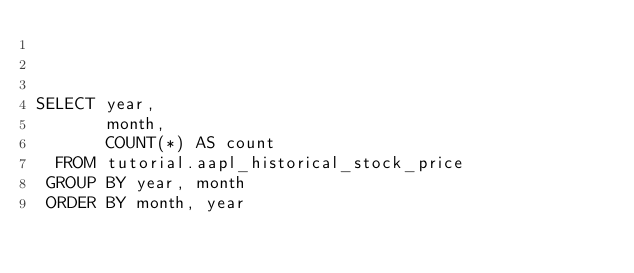<code> <loc_0><loc_0><loc_500><loc_500><_SQL_>


SELECT year,
       month,
       COUNT(*) AS count
  FROM tutorial.aapl_historical_stock_price
 GROUP BY year, month
 ORDER BY month, year
 
 
 
</code> 